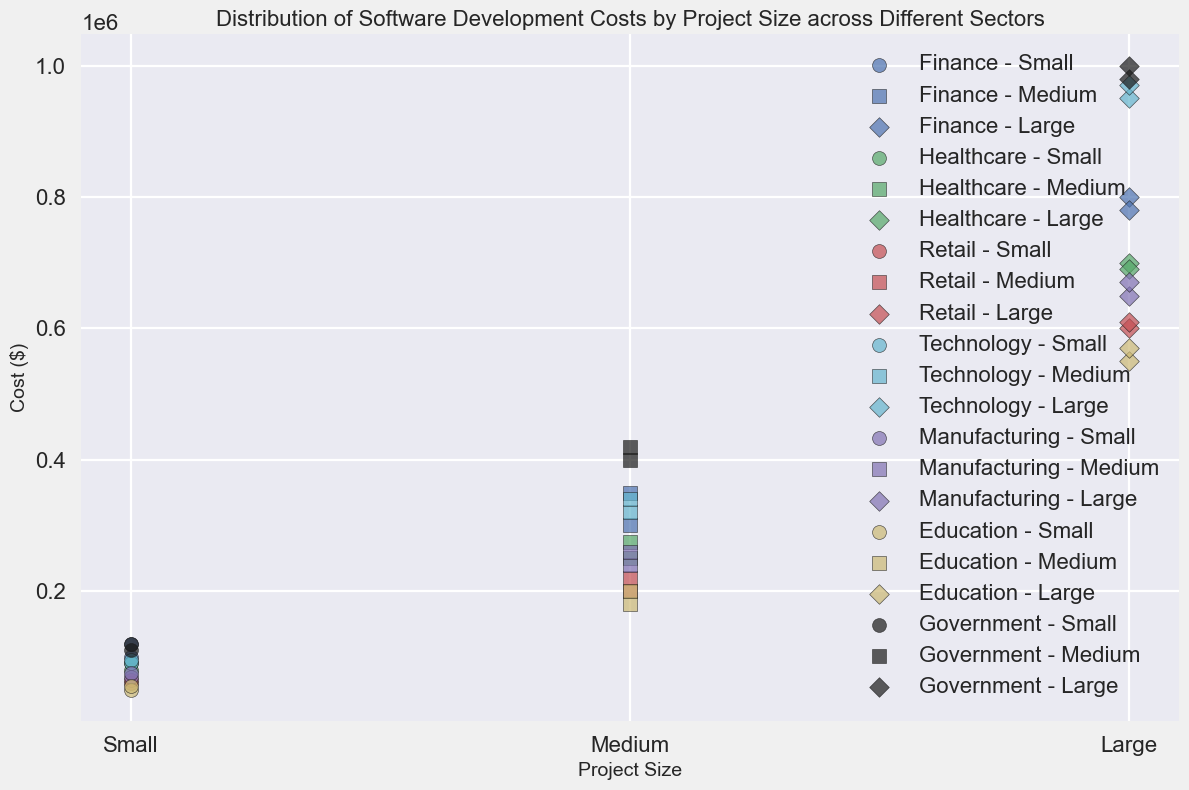What is the range of costs for large projects in the Technology sector? The plot shows two data points for large projects in the Technology sector. The minimum cost is $950,000, and the maximum cost is $970,000. Thus, the range is $970,000 - $950,000 = $20,000.
Answer: $20,000 Which sector has the highest cost for small projects? The scatter plot uses different colors for different sectors. The highest cost for small projects can be found by identifying the topmost marker in the ‘small’ category. The Government sector has the highest cost for small projects, with costs at $120,000 and $110,000.
Answer: Government What is the average cost of medium-sized projects in the Healthcare sector? Identify the costs of medium-sized projects in the Healthcare sector, which are $250,000 and $275,000. Calculate the average: ($250,000 + $275,000) / 2 = $262,500.
Answer: $262,500 Is the cost of large projects in the Retail sector greater than the cost of medium projects in the Manufacturing sector? Compare the large project costs in the Retail sector ($600,000 and $610,000) with medium project costs in the Manufacturing sector ($240,000 and $260,000). Both large project costs in Retail are greater than the medium project costs in Manufacturing.
Answer: Yes Among all sectors, which has the lowest cost for medium projects? Examine the costs associated with medium projects across all sectors. The lowest cost for medium projects is $180,000 found in the Education sector.
Answer: Education For small projects, does the Finance sector have higher costs compared to the Retail sector on average? Calculate the average cost for small projects in both the Finance and Retail sectors. Finance: ($100,000 + $120,000) / 2 = $110,000. Retail: ($60,000 + $65,000) / 2 = $62,500. Compare the averages: $110,000 > $62,500.
Answer: Yes What is the difference in the highest and lowest costs for large projects in the Government sector? Identify the highest and lowest costs for large projects in the Government sector, which are $1,000,000 and $980,000 respectively. Calculate the difference: $1,000,000 - $980,000 = $20,000.
Answer: $20,000 How many sectors have large project costs exceeding $900,000? Check the large project costs across all sectors. Only the Government and Technology sectors have costs exceeding $900,000 for large projects.
Answer: 2 Are the costs of small projects in the Healthcare sector generally lower than in the Technology sector? Review the scatter plot for small project costs in both sectors. Healthcare has costs of $80,000 and $90,000, whereas Technology has costs of $90,000 and $95,000. Both costs in Healthcare are lower than in Technology.
Answer: Yes 